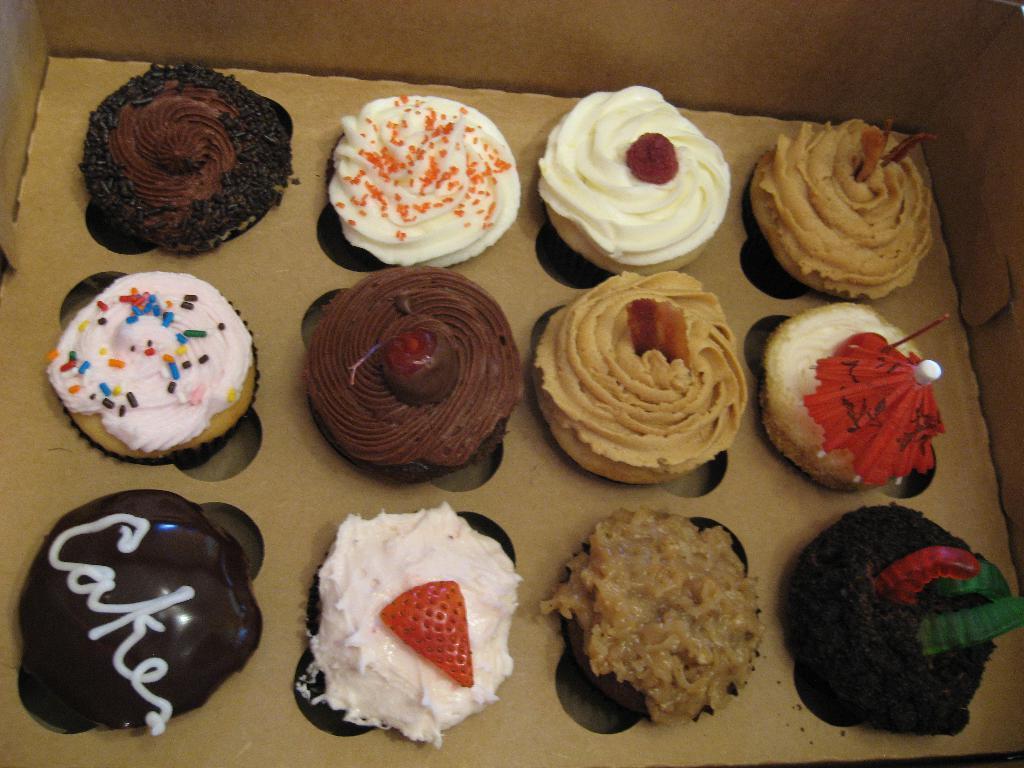Describe this image in one or two sentences. This image consists of cupcakes which are in the center. 